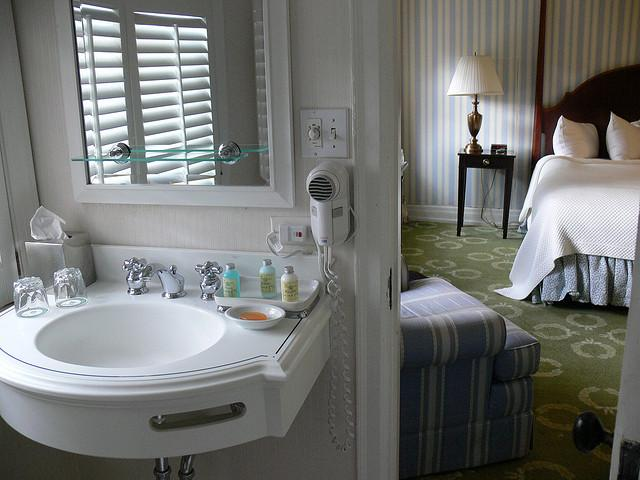What is on the bed? Please explain your reasoning. pillows. These are fluffy stuffed fabric for your head 